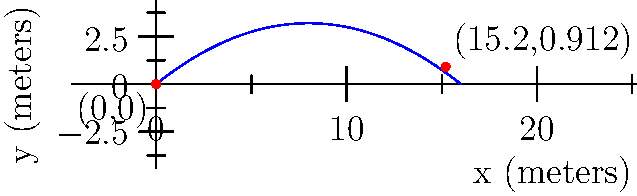As a competitive marksman, you're analyzing the trajectory of a bullet fired horizontally. The path of the bullet can be modeled by the parabolic function $f(x)=-0.05x^2+0.8x$, where $x$ and $y$ are measured in meters. If the bullet hits a target at ground level 15.2 meters away from the firing point, what is the maximum height reached by the bullet during its flight? To find the maximum height of the bullet's trajectory, we need to follow these steps:

1) The trajectory is given by the function $f(x)=-0.05x^2+0.8x$

2) To find the maximum point, we need to find where the derivative of this function equals zero:
   $f'(x) = -0.1x + 0.8$
   Set $f'(x) = 0$:
   $-0.1x + 0.8 = 0$
   $-0.1x = -0.8$
   $x = 8$

3) This x-coordinate (8 meters) represents the horizontal distance where the bullet reaches its maximum height.

4) To find the maximum height, we plug this x-value back into our original function:
   $f(8) = -0.05(8)^2 + 0.8(8)$
   $    = -0.05(64) + 6.4$
   $    = -3.2 + 6.4$
   $    = 3.2$

Therefore, the maximum height reached by the bullet is 3.2 meters.
Answer: 3.2 meters 